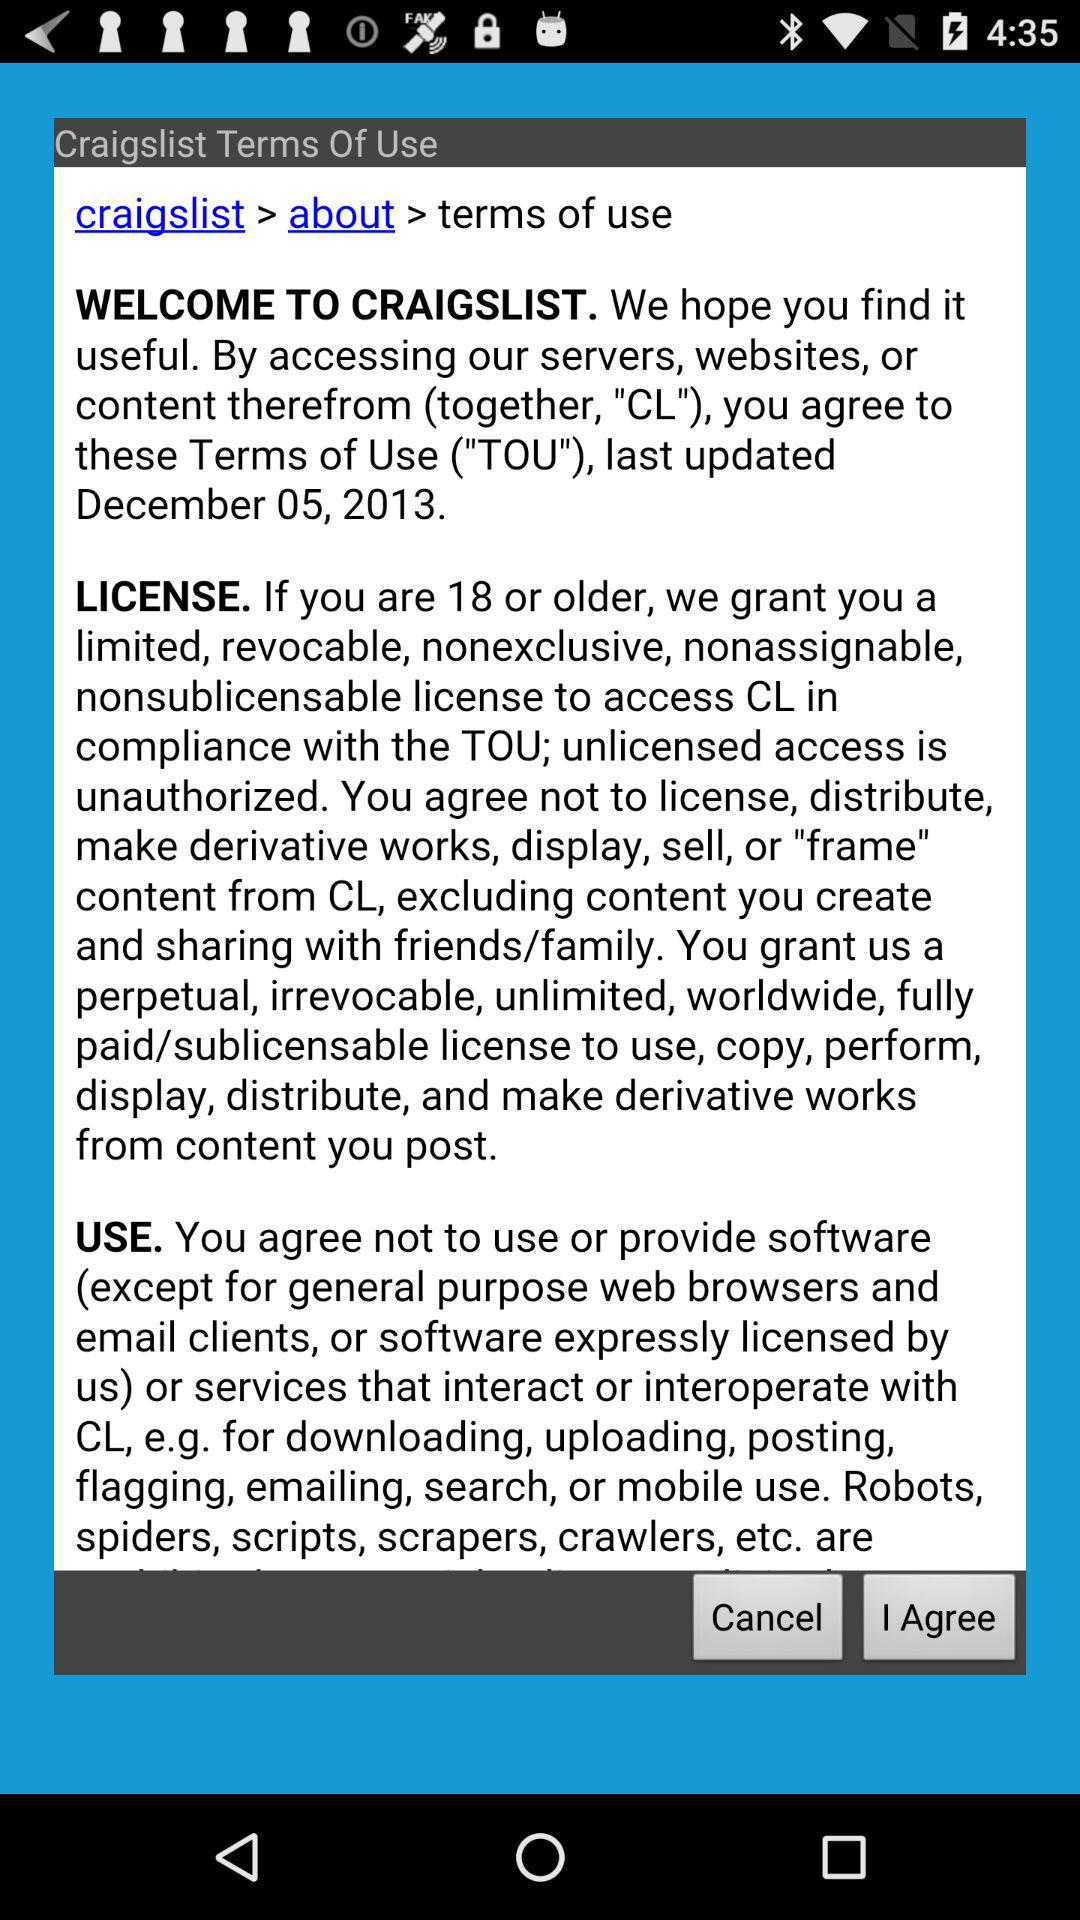On what date was the content last updated? The content was last updated on December 5, 2013. 